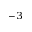Convert formula to latex. <formula><loc_0><loc_0><loc_500><loc_500>^ { - 3 }</formula> 